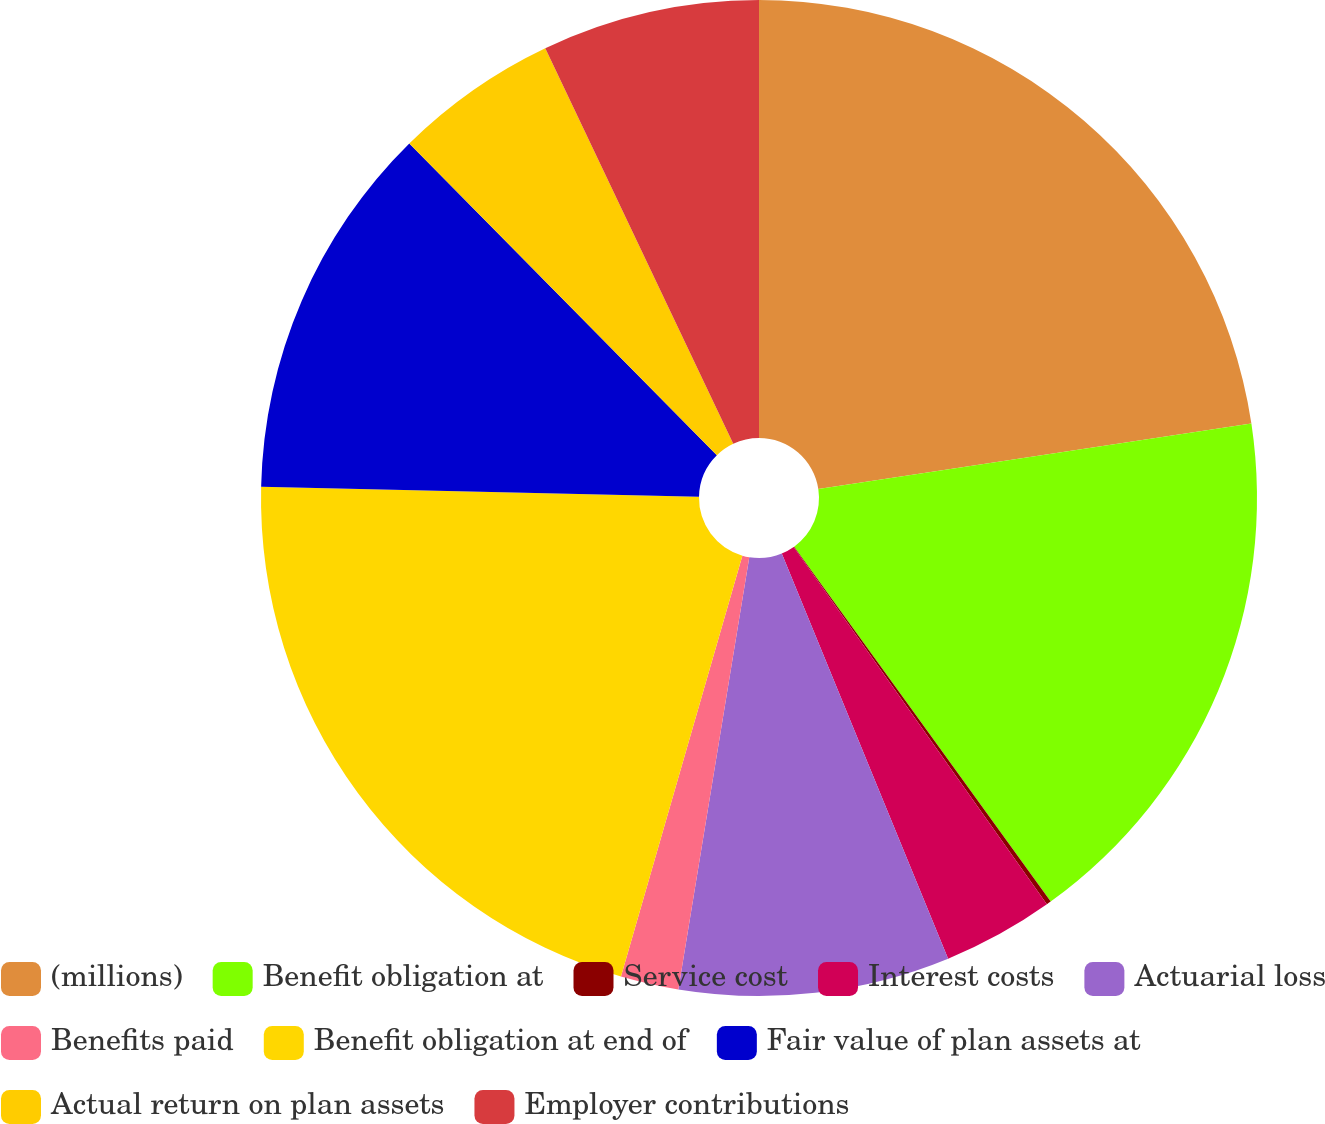<chart> <loc_0><loc_0><loc_500><loc_500><pie_chart><fcel>(millions)<fcel>Benefit obligation at<fcel>Service cost<fcel>Interest costs<fcel>Actuarial loss<fcel>Benefits paid<fcel>Benefit obligation at end of<fcel>Fair value of plan assets at<fcel>Actual return on plan assets<fcel>Employer contributions<nl><fcel>22.61%<fcel>17.43%<fcel>0.15%<fcel>3.61%<fcel>8.79%<fcel>1.88%<fcel>20.89%<fcel>12.25%<fcel>5.33%<fcel>7.06%<nl></chart> 